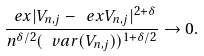<formula> <loc_0><loc_0><loc_500><loc_500>\frac { \ e x | V _ { n , j } - \ e x V _ { n , j } | ^ { 2 + \delta } } { n ^ { \delta / 2 } ( \ v a r ( V _ { n , j } ) ) ^ { 1 + \delta / 2 } } \to 0 .</formula> 